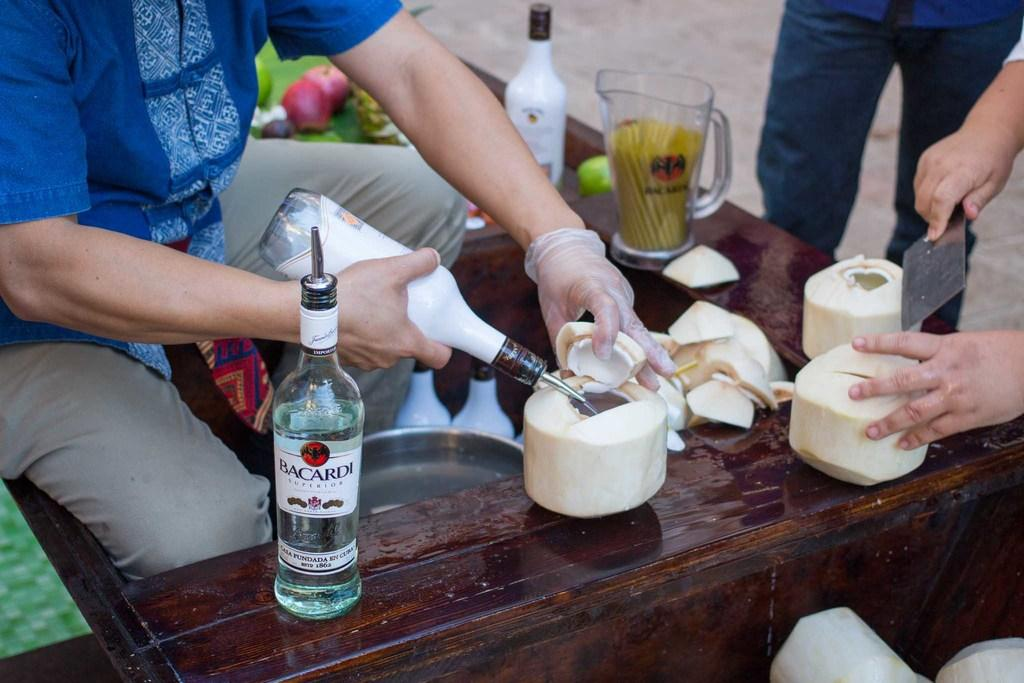<image>
Summarize the visual content of the image. People putting Bacardi alcohol inside some cut up coconuts. 